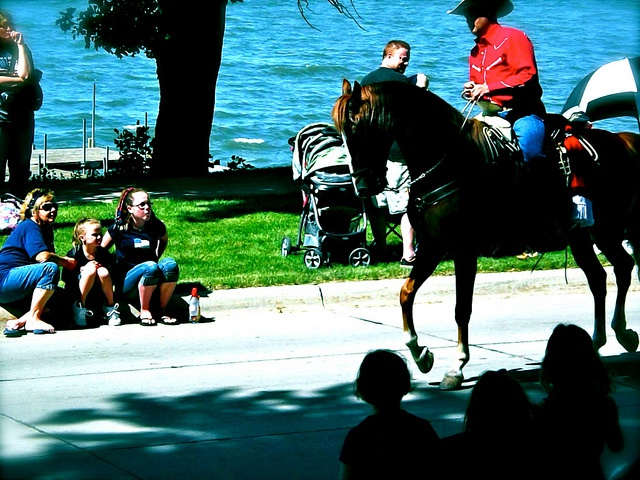Describe the objects in this image and their specific colors. I can see horse in teal, black, white, and maroon tones, people in teal, black, and lightblue tones, people in teal, black, red, and salmon tones, people in teal, black, and darkgreen tones, and people in teal, black, and lightblue tones in this image. 